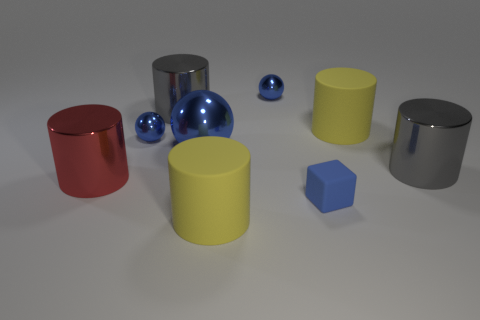Subtract all gray shiny cylinders. How many cylinders are left? 3 Subtract all red blocks. How many gray cylinders are left? 2 Add 1 big blue shiny balls. How many objects exist? 10 Subtract all gray cylinders. How many cylinders are left? 3 Subtract 1 spheres. How many spheres are left? 2 Subtract all spheres. How many objects are left? 6 Subtract all gray spheres. Subtract all gray cylinders. How many spheres are left? 3 Subtract all large yellow cylinders. Subtract all large gray shiny things. How many objects are left? 5 Add 8 blue blocks. How many blue blocks are left? 9 Add 2 blue objects. How many blue objects exist? 6 